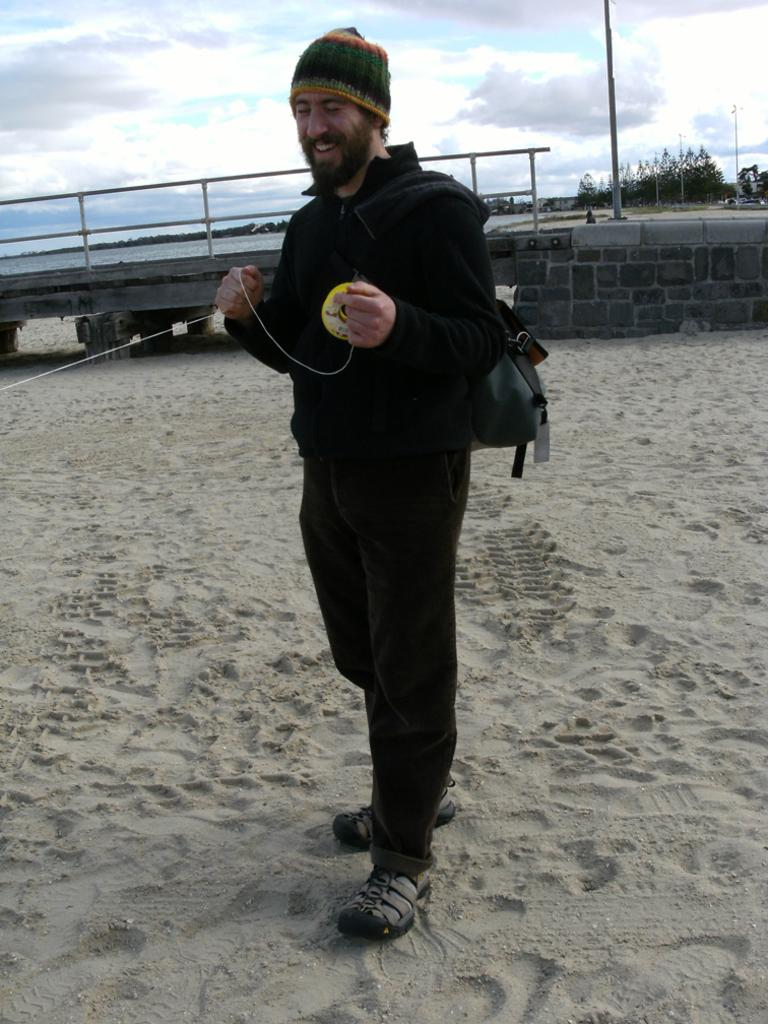What is the person in the image doing with the objects they are holding? The fact does not specify what the person is doing with the objects, so we cannot answer this question definitively. What type of surface can be seen under the person's feet in the image? There is ground with sand visible in the image. What type of structure is present in the image? There is a bridge in the image. What type of vegetation is present in the image? There are trees in the image. What type of vertical structures are present in the image? There are poles in the image. What part of the natural environment is visible in the image? The sky is visible in the image. What type of weather can be inferred from the image? Clouds are present in the sky, which suggests that it might be a partly cloudy day. What type of tax is being discussed in the image? There is no mention of tax or any discussion in the image, so we cannot answer this question definitively. 